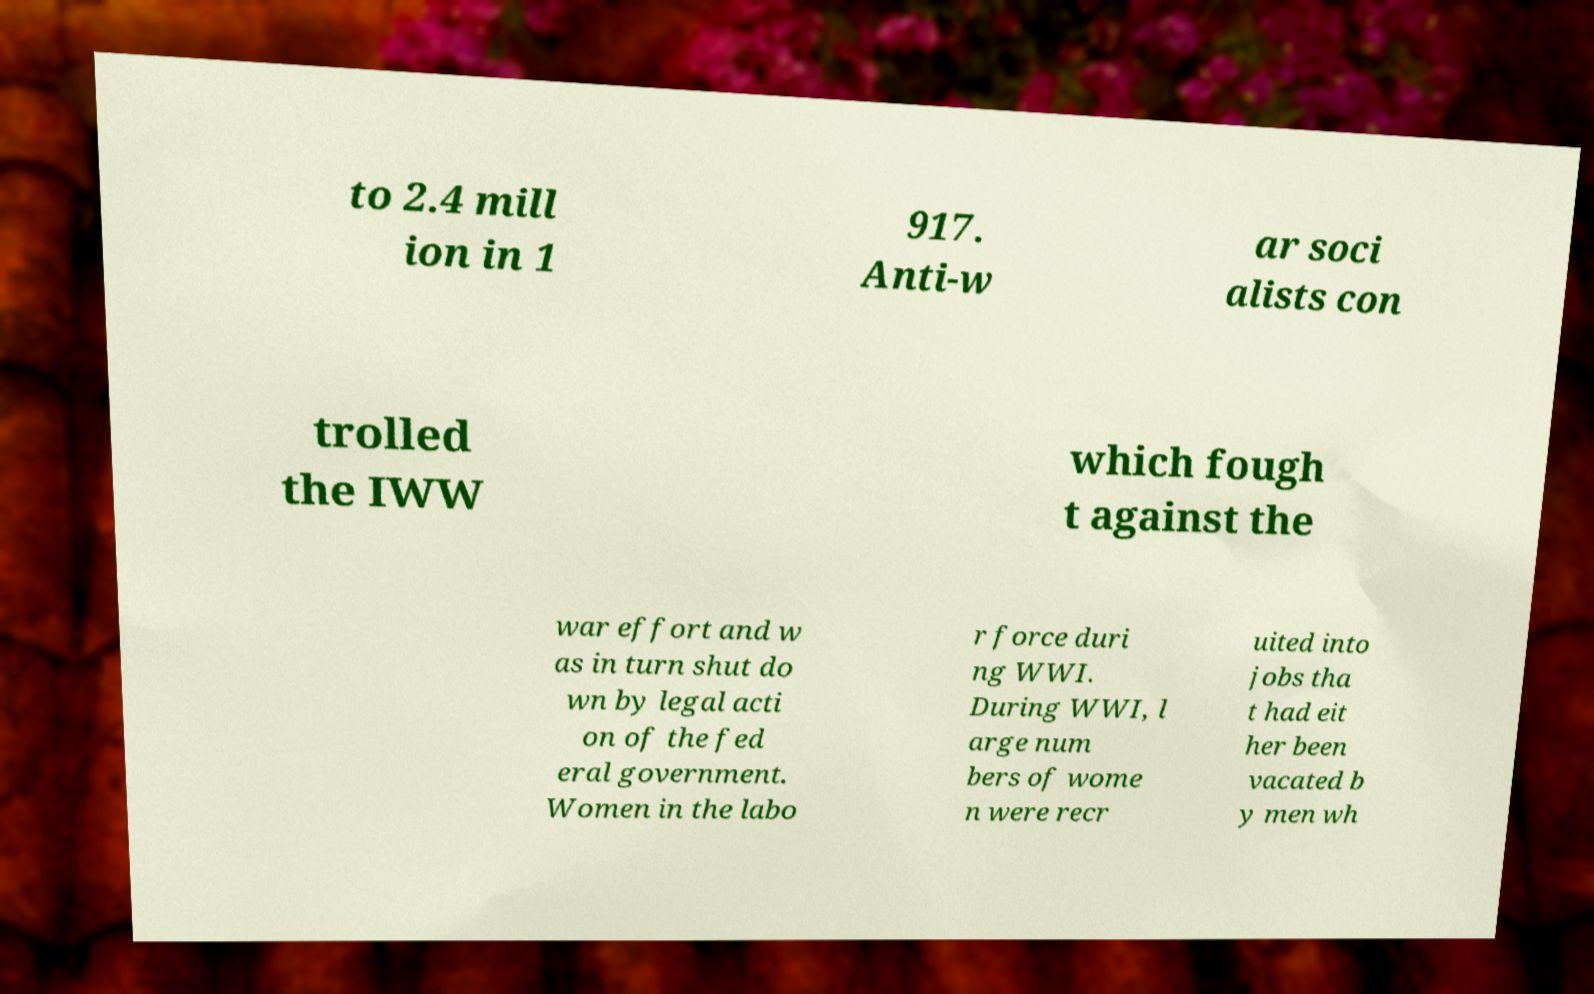What messages or text are displayed in this image? I need them in a readable, typed format. to 2.4 mill ion in 1 917. Anti-w ar soci alists con trolled the IWW which fough t against the war effort and w as in turn shut do wn by legal acti on of the fed eral government. Women in the labo r force duri ng WWI. During WWI, l arge num bers of wome n were recr uited into jobs tha t had eit her been vacated b y men wh 